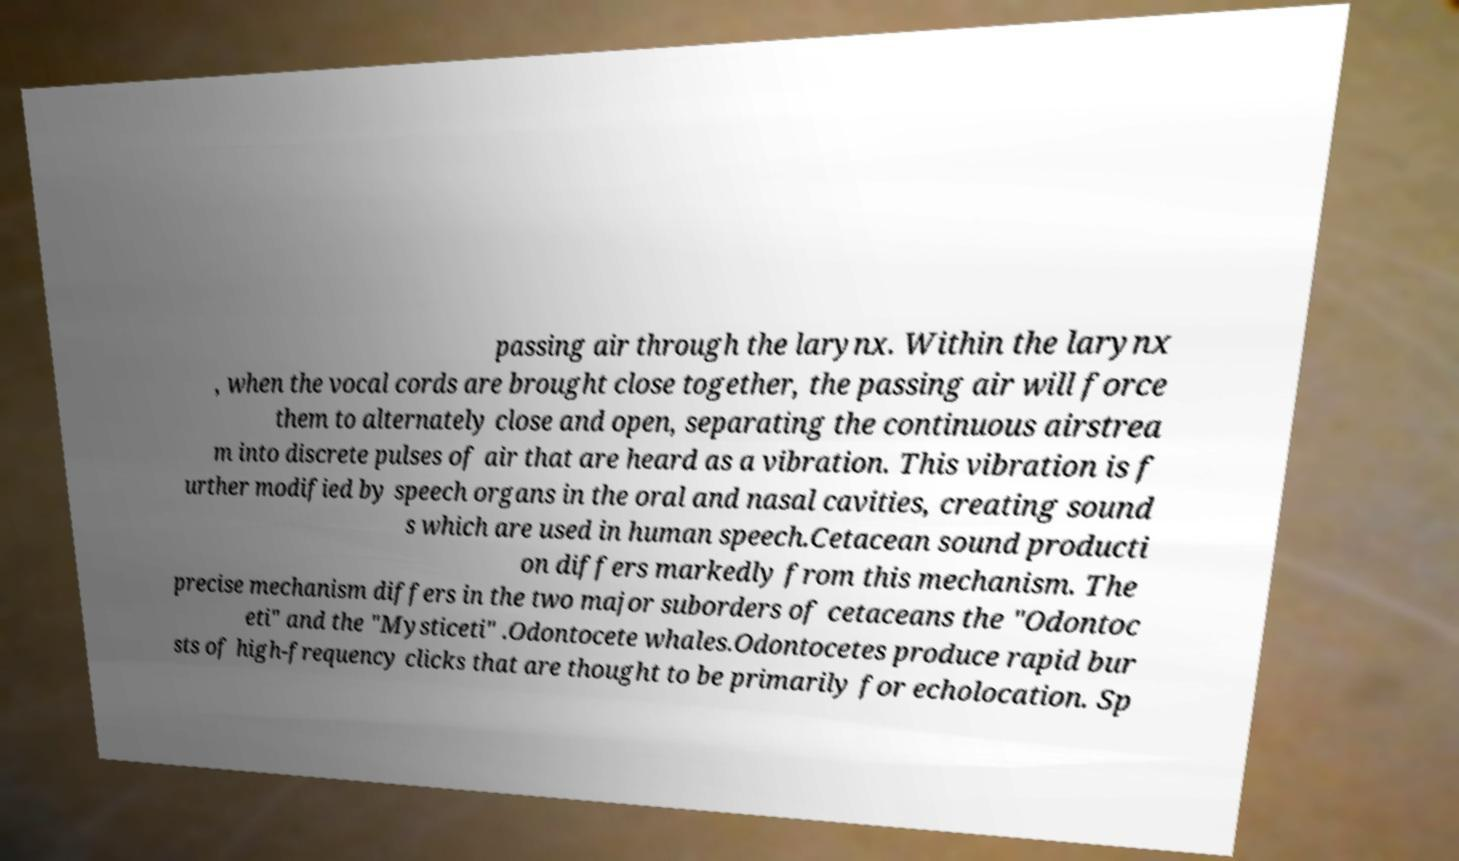Please read and relay the text visible in this image. What does it say? passing air through the larynx. Within the larynx , when the vocal cords are brought close together, the passing air will force them to alternately close and open, separating the continuous airstrea m into discrete pulses of air that are heard as a vibration. This vibration is f urther modified by speech organs in the oral and nasal cavities, creating sound s which are used in human speech.Cetacean sound producti on differs markedly from this mechanism. The precise mechanism differs in the two major suborders of cetaceans the "Odontoc eti" and the "Mysticeti" .Odontocete whales.Odontocetes produce rapid bur sts of high-frequency clicks that are thought to be primarily for echolocation. Sp 